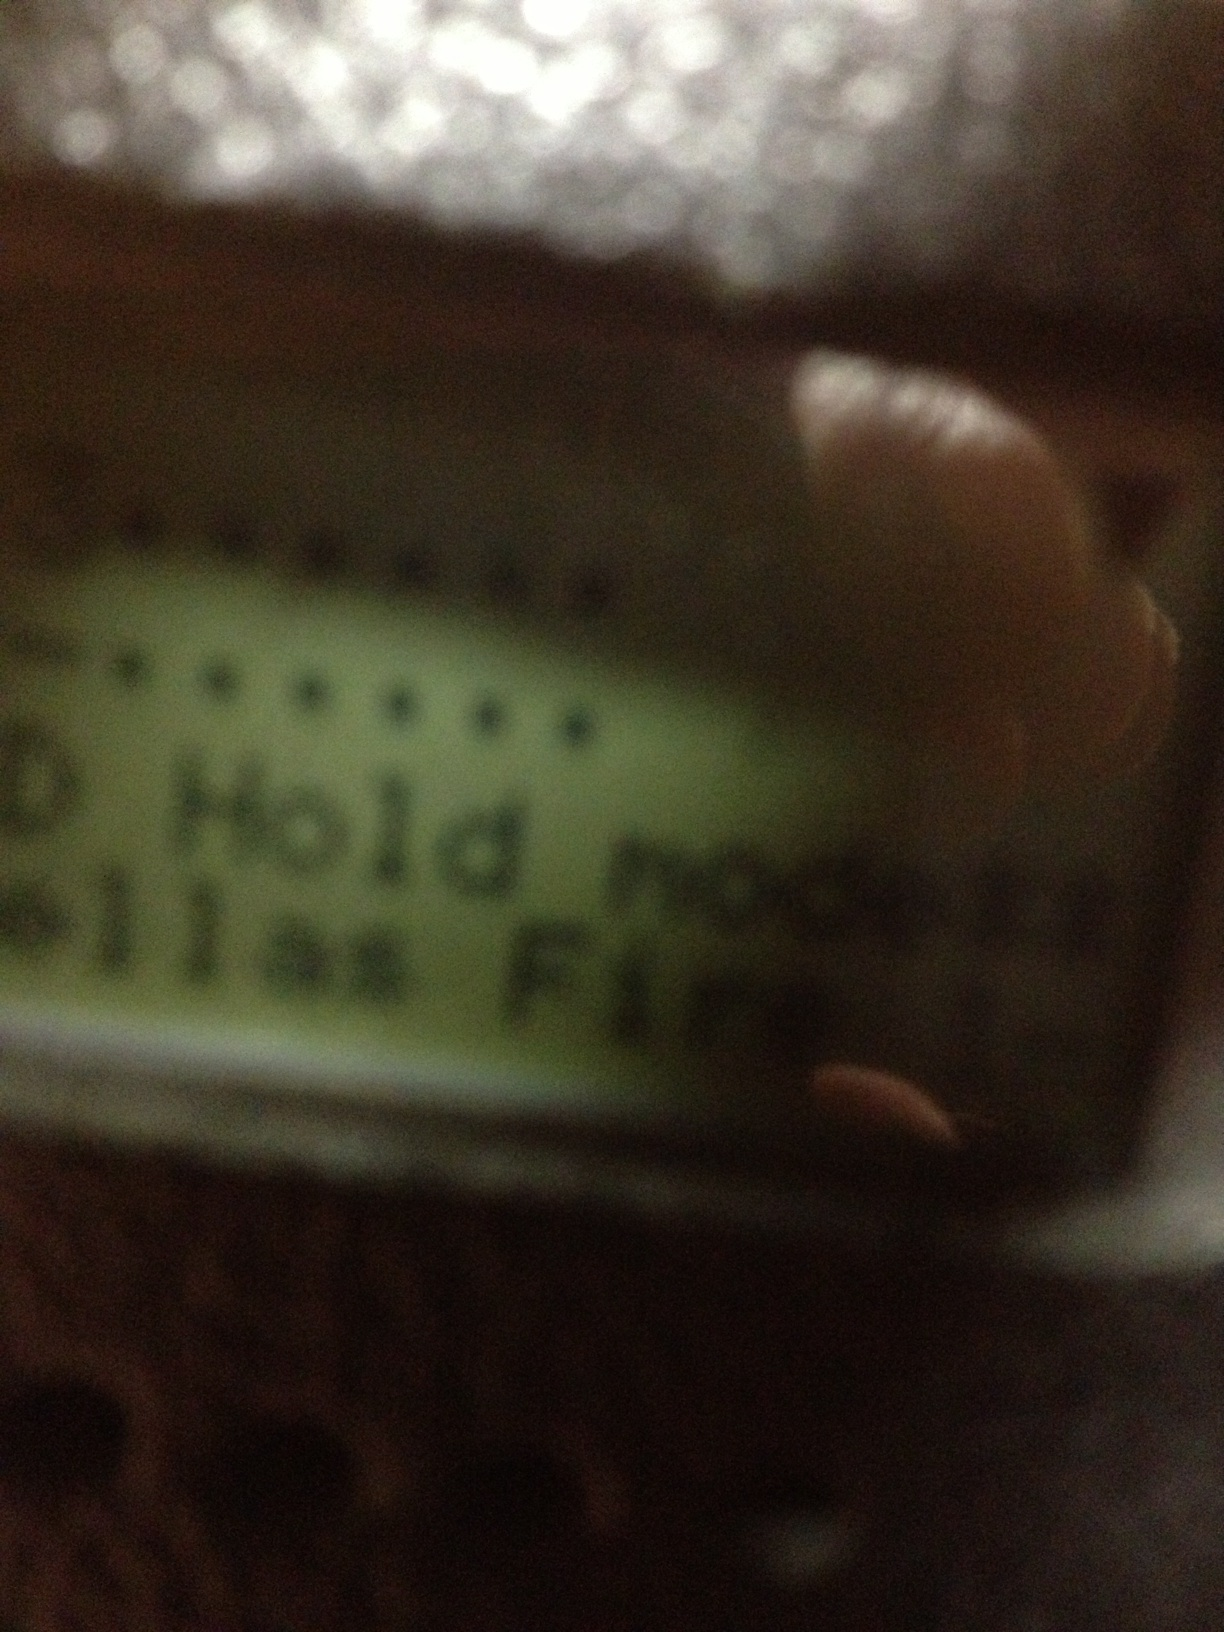Describe a scenario where 'Hold mode' would be used on this device. A plausible scenario for 'Hold mode' on this device could be during an emergency where the device temporarily halts any non-essential operations to focus on a critical alert. For example, in a fire alarm system, the 'Hold mode' might be activated to ensure that all resources are directed towards managing the alarm and notifying appropriate personnel, pausing any non-critical notifications or processes. Imagine this device in an industrial setting. How might it function? In an industrial setting, this device could function as part of a control system, monitoring various parameters. In 'Hold mode', it might temporarily pause processes to prevent overloads or errors, notify the control center of a paused state, and await further instructions. This ensures that any issues are acknowledged and addressed before resuming normal operations, possibly preventing accidents or equipment damage. What if this device is used in a spaceship? Get creative! Imagine this device as part of a spaceship's control panel. In 'Hold mode', it pauses normal operations of the spaceship to prepare for an external event, such as an unexpected asteroid field. The device might halt non-essential systems to conserve power, reroute energy to shields or evasive maneuvers, and alert the crew to don space suits in preparation for potential impacts. 'Hold mode' would be crucial for ensuring the spaceship's safety and the crew's readiness for the approaching challenge. Give a short realistic scenario where 'Hold mode' is activated in a household device. In a household device like an advanced oven, 'Hold mode' could be activated if the device senses an overheating condition, pausing the cooking process to avoid accidents and notifying the user to check the oven. Describe a long realistic scenario where 'Hold mode' could be applied in a medical device. In a medical device used in hospitals, 'Hold mode' might be part of a patient monitoring system. If the device detects an irregularity in the patient's vitals, it enters 'Hold mode' to pause data logging and focus on immediate alert notifications. The system prioritizes sending critical alerts to healthcare professionals, displaying detailed information on the screen, and running diagnostics to ensure accurate data before proceeding. This pause helps avoid potential data corruption during high-stress moments and ensures that healthcare providers can swiftly respond to the patient's needs. 